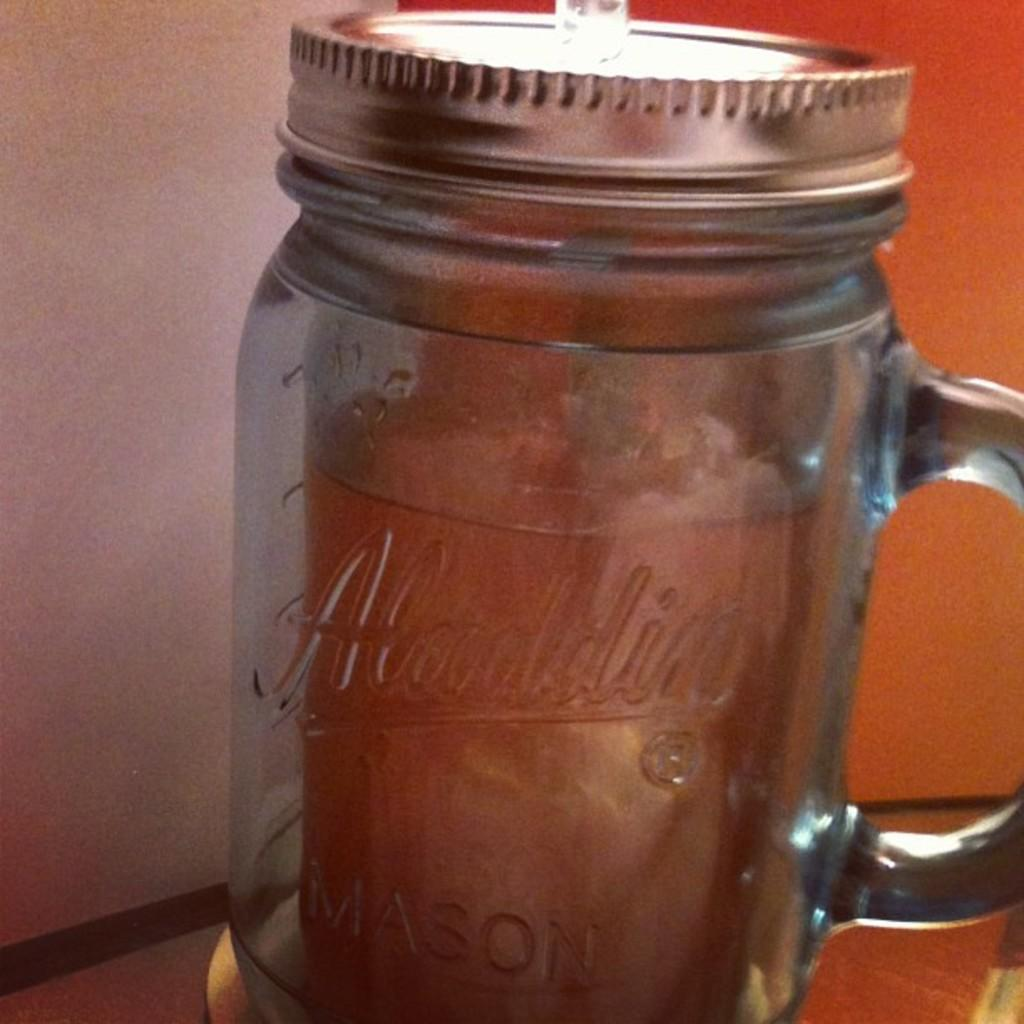What type of container is visible in the image? There is a glass jar in the image. What is covering the top of the glass jar? The glass jar has a metal lid. What color is the metal lid? The metal lid is ash in color. What can be seen in the background of the image? There is a white and orange colored surface in the background of the image. How does the glass jar control the temperature of the room in the image? The glass jar does not control the temperature of the room in the image; it is a container with a metal lid. 